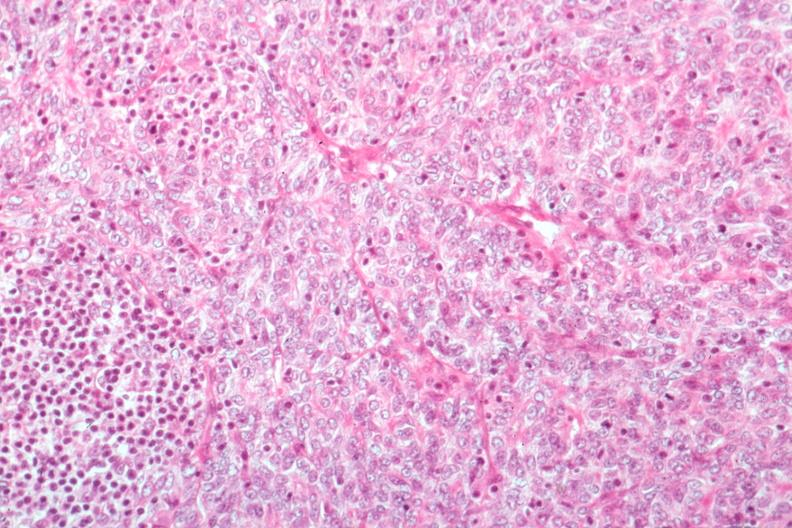what does this image show?
Answer the question using a single word or phrase. Predominant epithelial excellent histology 